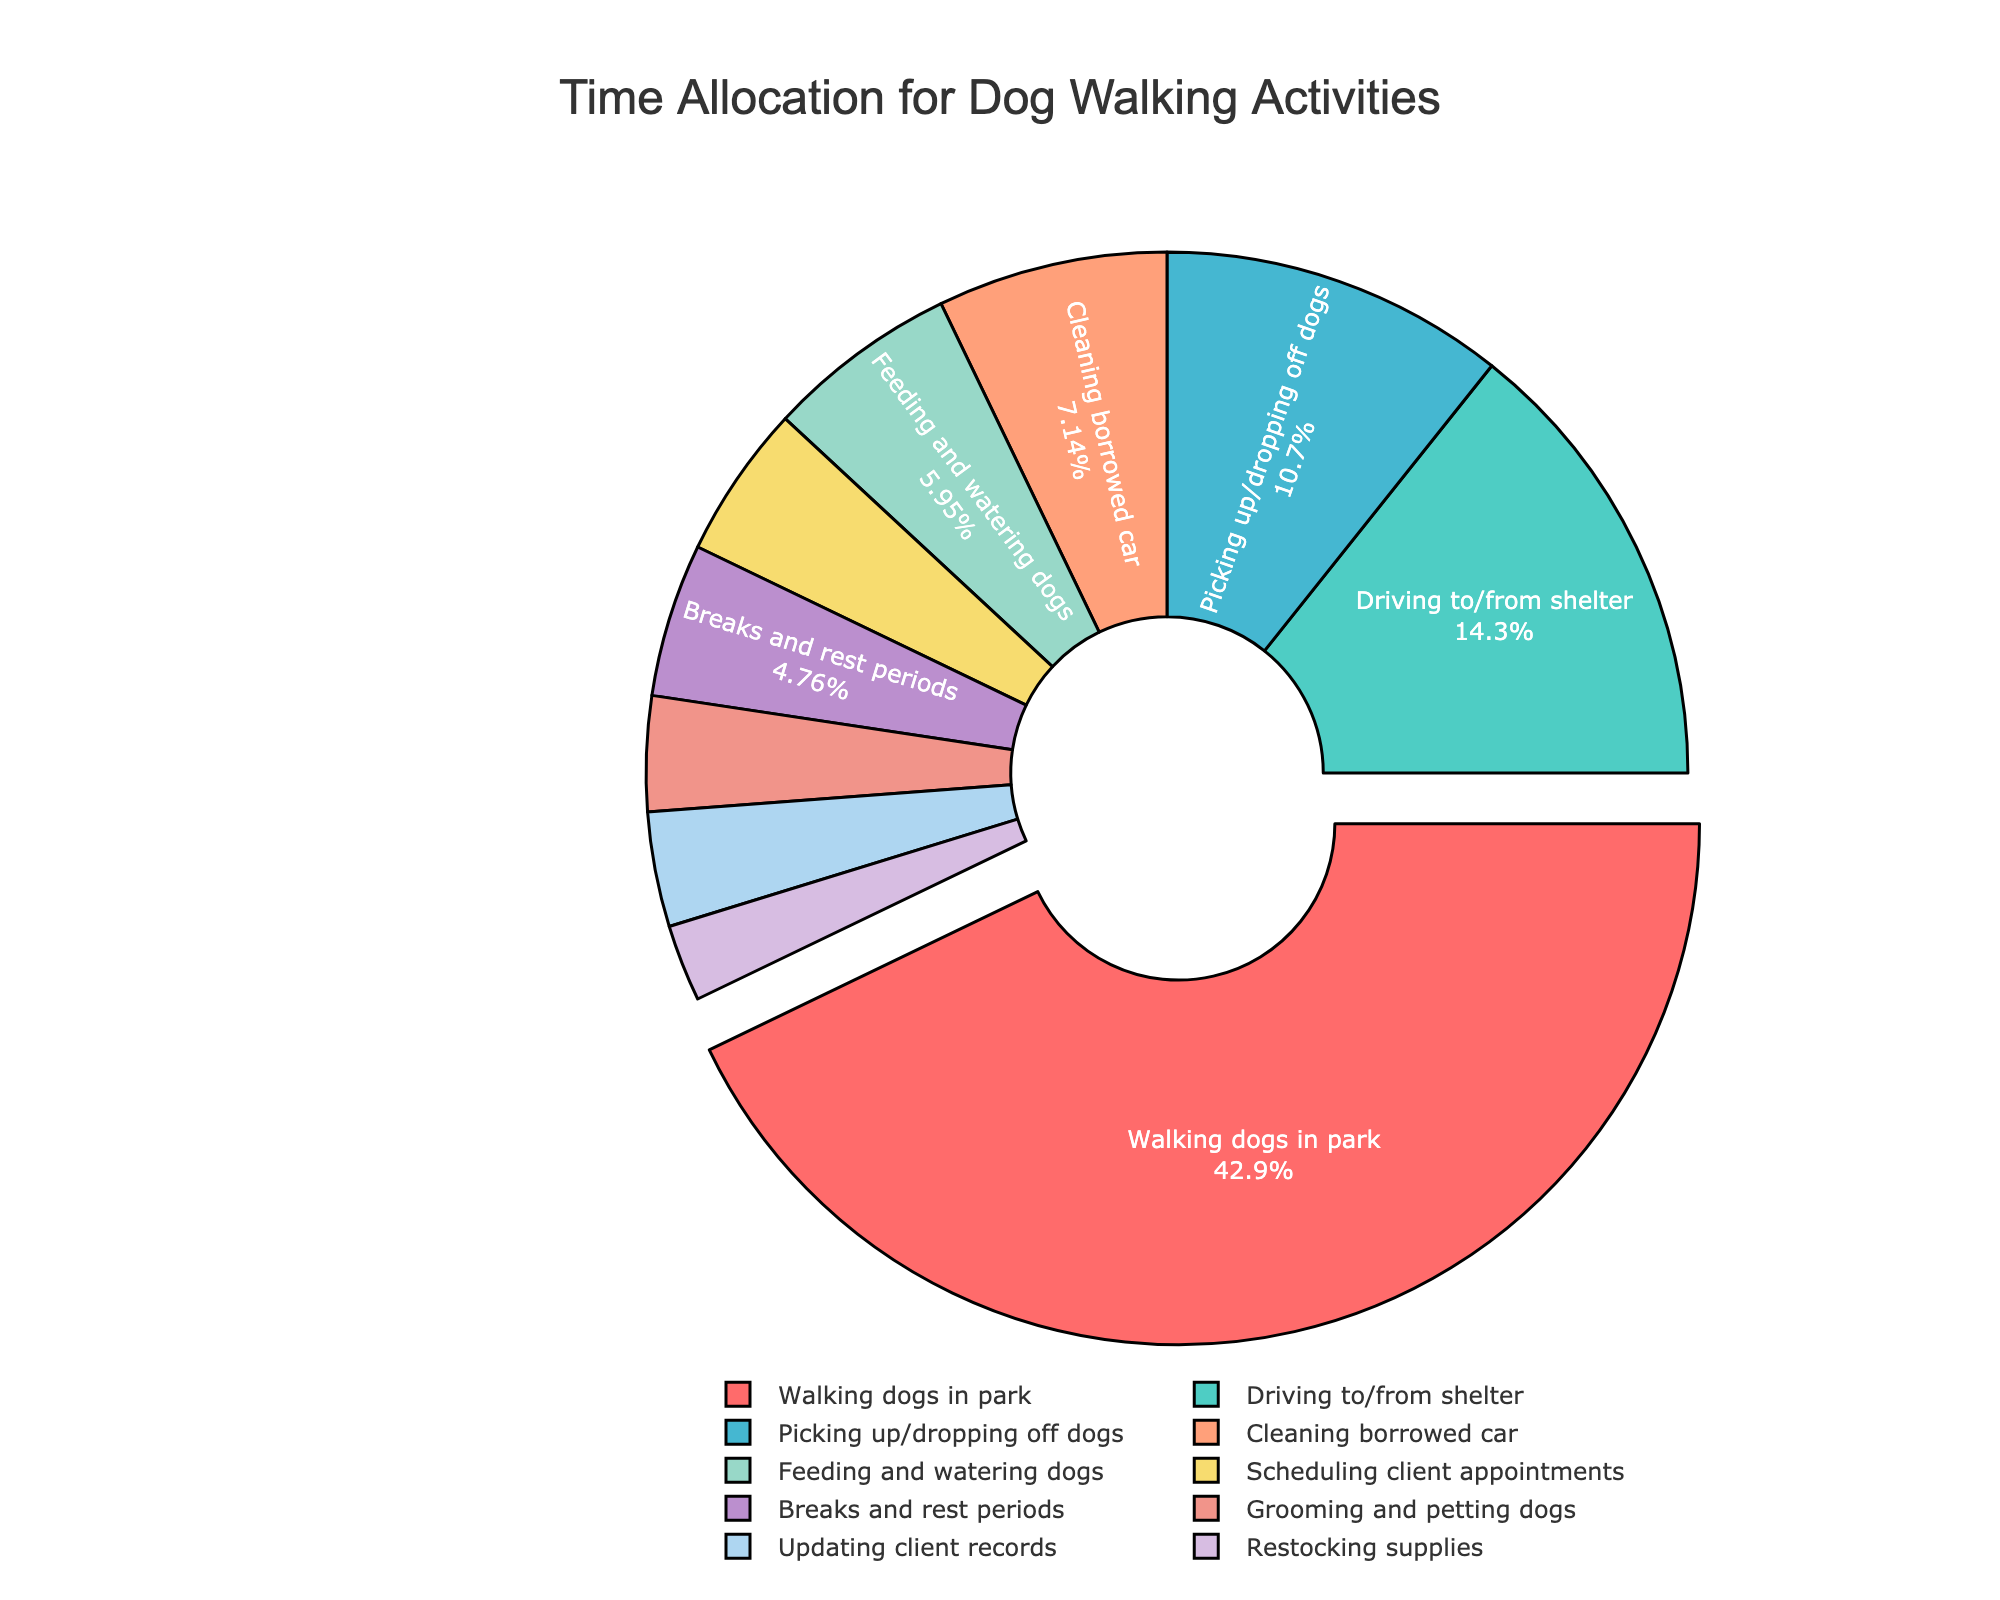What activity takes up the largest portion of the workday? The pie chart clearly shows that the largest segment is for "Walking dogs in park," which visually takes up the largest area in the pie, indicating it occupies the most time.
Answer: Walking dogs in park Which two activities together take up more than half of the workday? By examining the pie chart, "Walking dogs in park" and "Driving to/from shelter" are the two largest segments. Summing their percentages (45% + 15%) shows that together they account for more than 60% of the workday.
Answer: Walking dogs in park and Driving to/from shelter What is the smallest activity in terms of time allocation? The smallest slice in the pie chart corresponds to the activity "Restocking supplies," which visually takes up the least space on the pie.
Answer: Restocking supplies How much time is spent on feeding and watering dogs compared to grooming and petting dogs? By looking at the pie chart, we see that the segments for "Feeding and watering dogs" and "Grooming and petting dogs" are differently sized. Feeding and watering dogs takes up a larger portion of the pie compared to grooming and petting dogs, indicating more time is allocated.
Answer: More time is spent on Feeding and watering dogs Is the time spent on scheduling client appointments greater than the time spent on grooming and petting dogs? The pie chart segments indicate the size of each activity, and the segment for "Scheduling client appointments" is larger than that for "Grooming and petting dogs." Therefore, more time is spent on scheduling client appointments.
Answer: Yes What percentage of the workday is spent on breaks and rest periods? The pie chart displays each activity's percentage, and "Breaks and rest periods" occupies one of the segments. By looking at this segment, it shows that 5% of the workday is spent on breaks and rest periods.
Answer: 5% How much more time is dedicated to picking up/dropping off dogs than to restocking supplies? The pie chart shows that "Picking up/dropping off dogs" and "Restocking supplies" are different in size. Picking up/dropping off dogs takes up a larger portion of the pie chart compared to restocking supplies. The difference can be calculated numerically by subtracting the time allocated to restocking supplies (10 minutes) from picking up/dropping off dogs (45 minutes).
Answer: 35 minutes Which activities together constitute roughly one-fourth of the workday? Examining the pie chart, we can sum segments that together represent around 25%. "Picking up/dropping off dogs" (11.25%) and "Cleaning borrowed car" (7.5%) together account for about 18.75%. Adding "Feeding and watering dogs" (6.25%) brings the total to roughly one-fourth.
Answer: Picking up/dropping off dogs, Cleaning borrowed car, and Feeding and watering dogs 